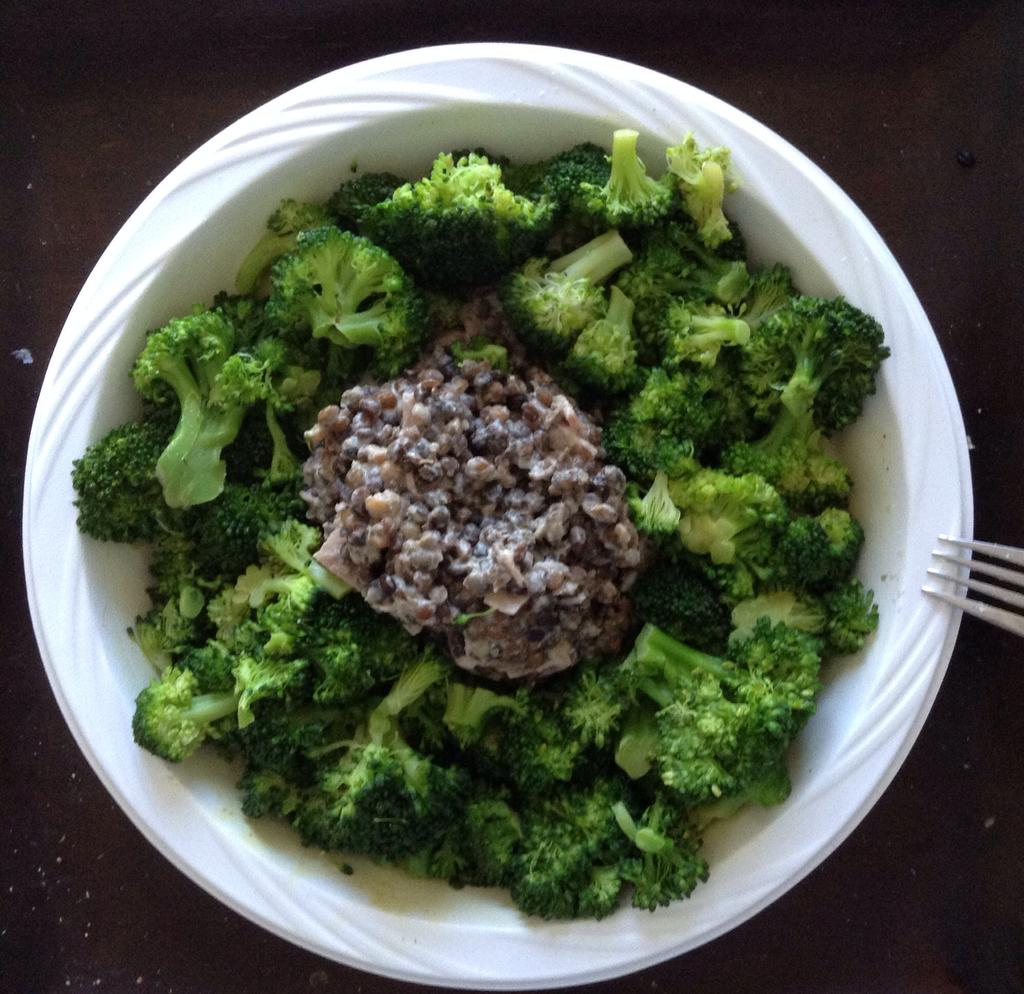What type of vegetable is present in the image? There is broccoli in the image. What is the color of the bowl containing food in the image? The bowl containing food is white. What utensil is visible on the right side of the image? There is a fork on the right side of the image. What can be seen behind the food and utensil in the image? The background of the image includes a surface. Is there a crown visible on the broccoli in the image? No, there is no crown present on the broccoli in the image. Is the food in the image surrounded by snow? No, there is no snow present in the image. 